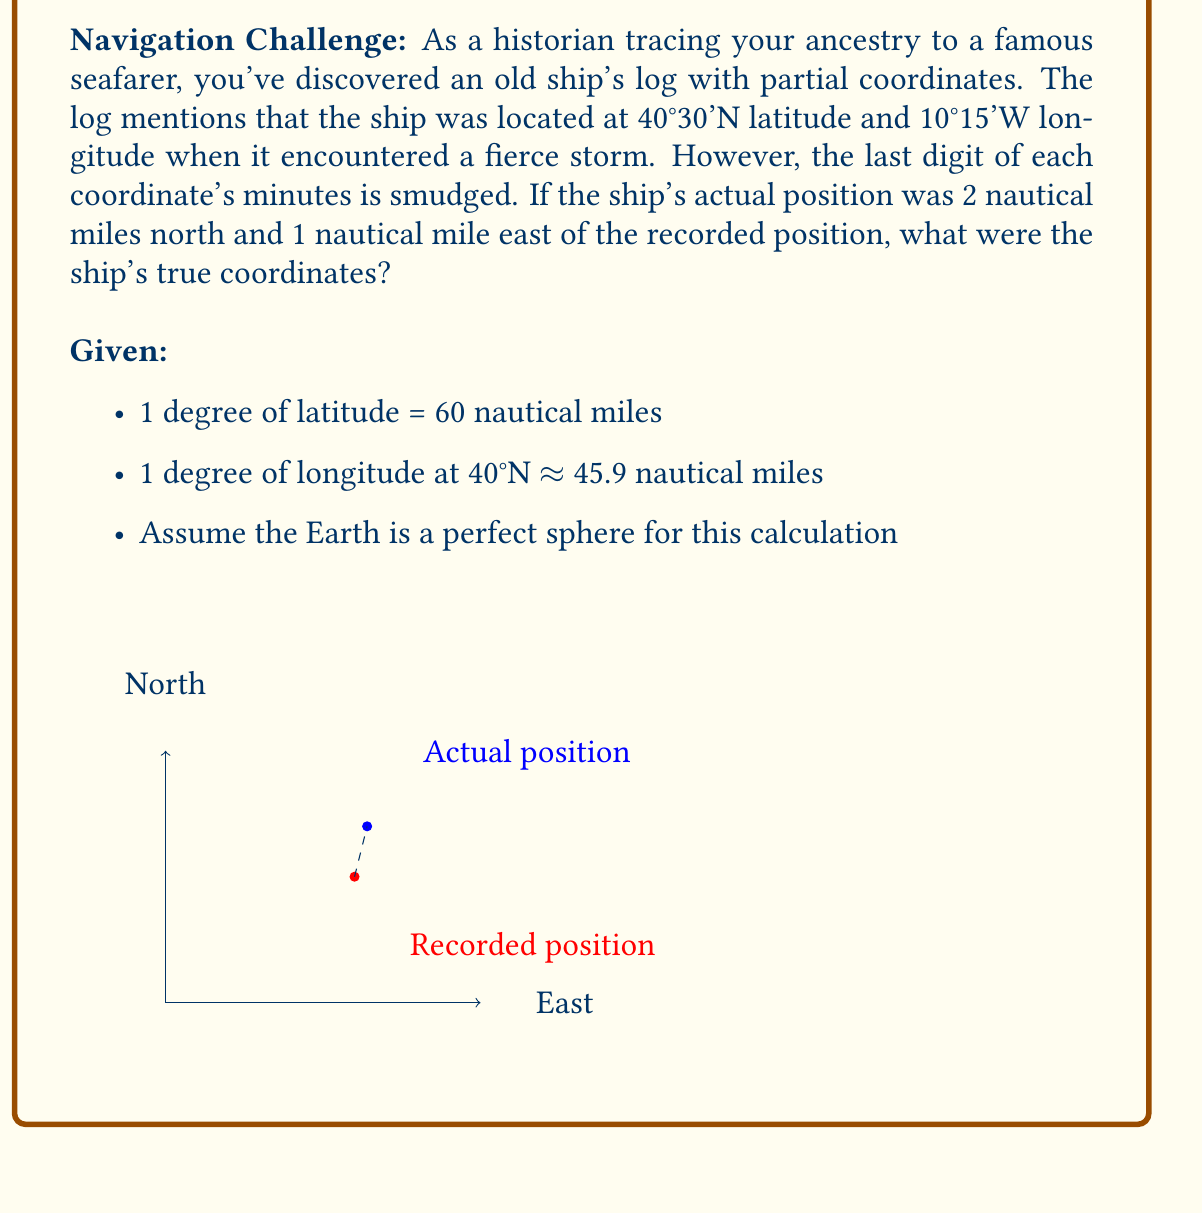Help me with this question. Let's approach this step-by-step:

1) First, we need to convert the given distances to degrees:

   For latitude:
   $\frac{2 \text{ nautical miles}}{60 \text{ nautical miles/degree}} = \frac{1}{30}$ degree = 2 minutes

   For longitude:
   $\frac{1 \text{ nautical mile}}{45.9 \text{ nautical miles/degree}} \approx 0.0218$ degree ≈ 1.31 minutes

2) Now, we can calculate the true coordinates:

   Latitude:
   40°30'N + 2' = 40°32'N

   Longitude:
   10°15'W - 1.31' = 10°13.69'W

3) Rounding to the nearest minute (as the original coordinates were given in minutes):

   Latitude: 40°32'N
   Longitude: 10°14'W

4) Therefore, the smudged digits in the original coordinates were:

   Latitude: 40°30'N should be 40°32'N
   Longitude: 10°15'W should be 10°14'W
Answer: 40°32'N, 10°14'W 